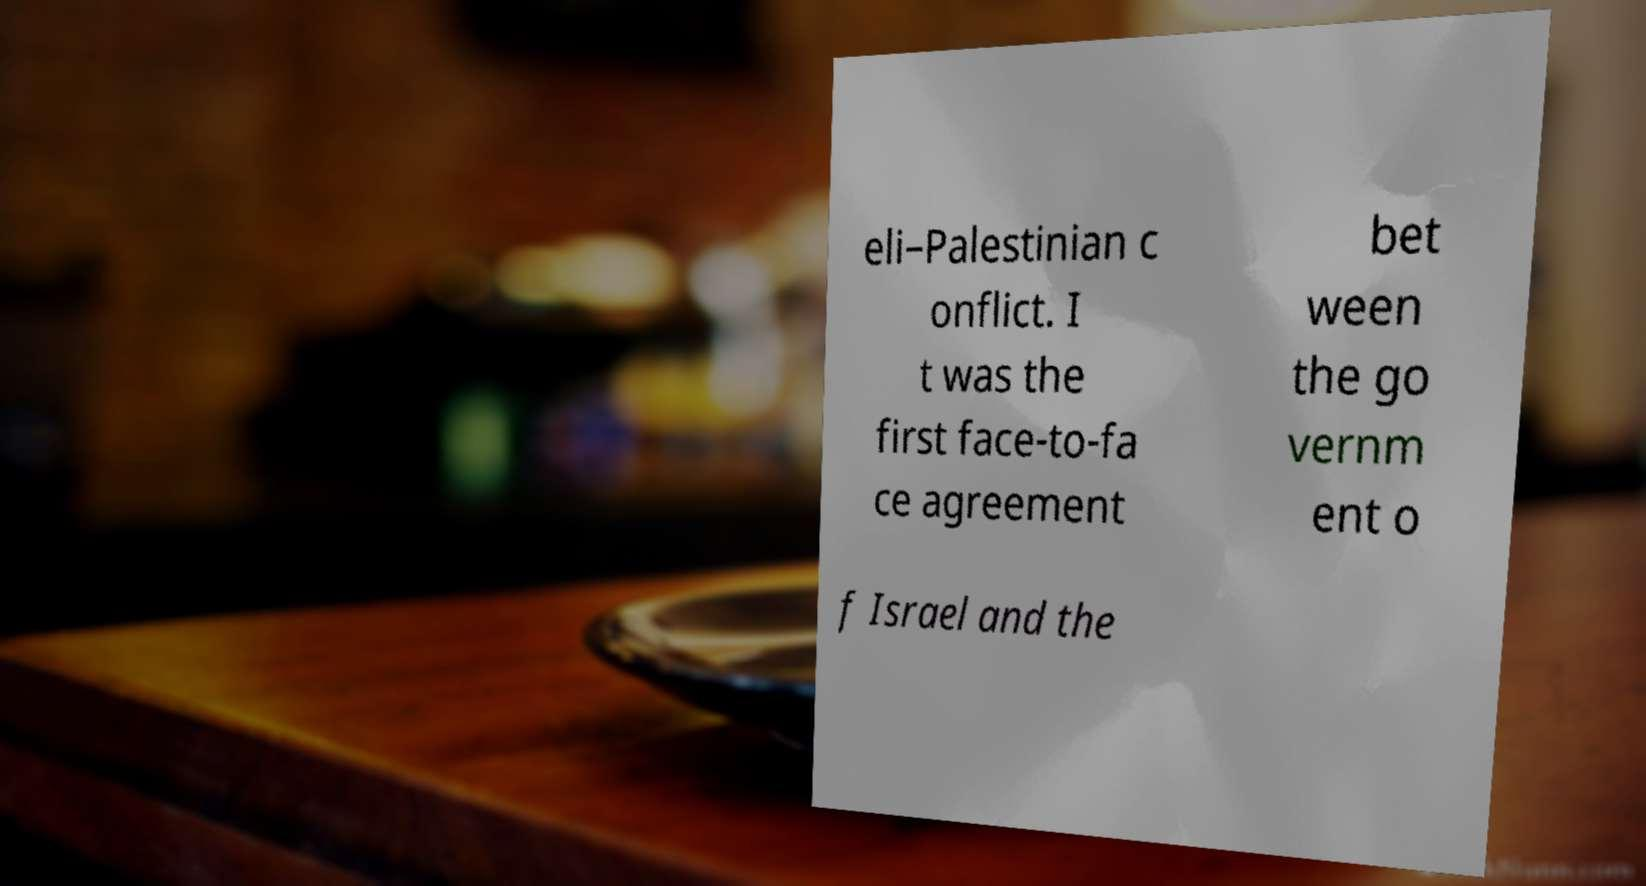What messages or text are displayed in this image? I need them in a readable, typed format. eli–Palestinian c onflict. I t was the first face-to-fa ce agreement bet ween the go vernm ent o f Israel and the 